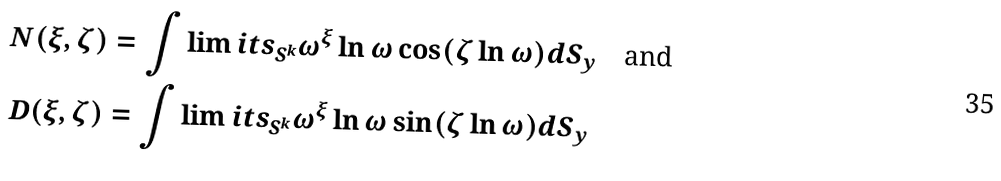<formula> <loc_0><loc_0><loc_500><loc_500>& N ( \xi , \zeta ) = \int \lim i t s _ { S ^ { k } } \omega ^ { \xi } \ln \omega \cos ( \zeta \ln \omega ) d S _ { y } \quad \text {and} \\ & D ( \xi , \zeta ) = \int \lim i t s _ { S ^ { k } } \omega ^ { \xi } \ln \omega \sin ( \zeta \ln \omega ) d S _ { y }</formula> 